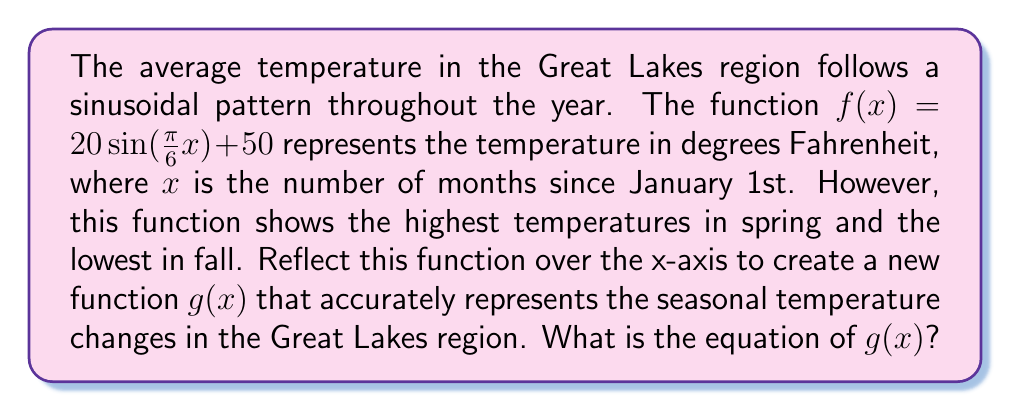Can you answer this question? To reflect a function over the x-axis, we need to negate the entire function, excluding any vertical shift. Let's approach this step-by-step:

1) The original function is $f(x) = 20 \sin(\frac{\pi}{6}x) + 50$

2) We can break this into two parts:
   - The sinusoidal part: $20 \sin(\frac{\pi}{6}x)$
   - The vertical shift: $50$

3) To reflect over the x-axis, we negate the sinusoidal part:
   $-20 \sin(\frac{\pi}{6}x)$

4) The vertical shift remains the same: $50$

5) Combining these parts, we get:
   $g(x) = -20 \sin(\frac{\pi}{6}x) + 50$

This new function $g(x)$ will have its maximum in summer (around July) and its minimum in winter (around January), accurately representing the seasonal temperature changes in the Great Lakes region.
Answer: $g(x) = -20 \sin(\frac{\pi}{6}x) + 50$ 